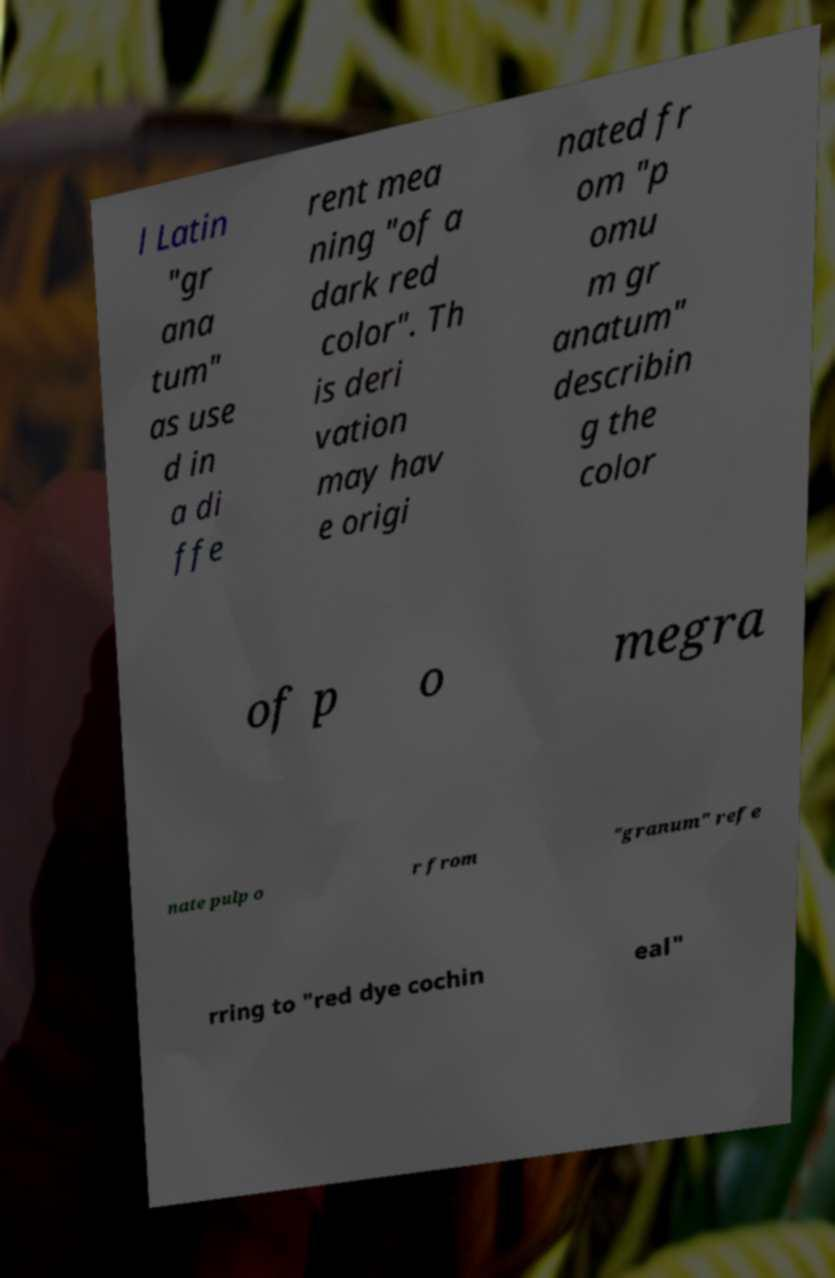Can you read and provide the text displayed in the image?This photo seems to have some interesting text. Can you extract and type it out for me? l Latin "gr ana tum" as use d in a di ffe rent mea ning "of a dark red color". Th is deri vation may hav e origi nated fr om "p omu m gr anatum" describin g the color of p o megra nate pulp o r from "granum" refe rring to "red dye cochin eal" 